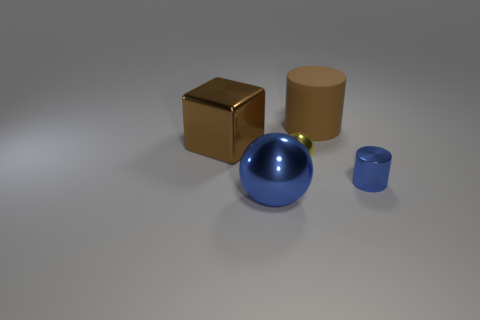Add 3 tiny yellow matte spheres. How many objects exist? 8 Subtract all spheres. How many objects are left? 3 Subtract 1 blue spheres. How many objects are left? 4 Subtract all cyan blocks. Subtract all big blue shiny spheres. How many objects are left? 4 Add 5 yellow metal spheres. How many yellow metal spheres are left? 6 Add 5 large gray shiny things. How many large gray shiny things exist? 5 